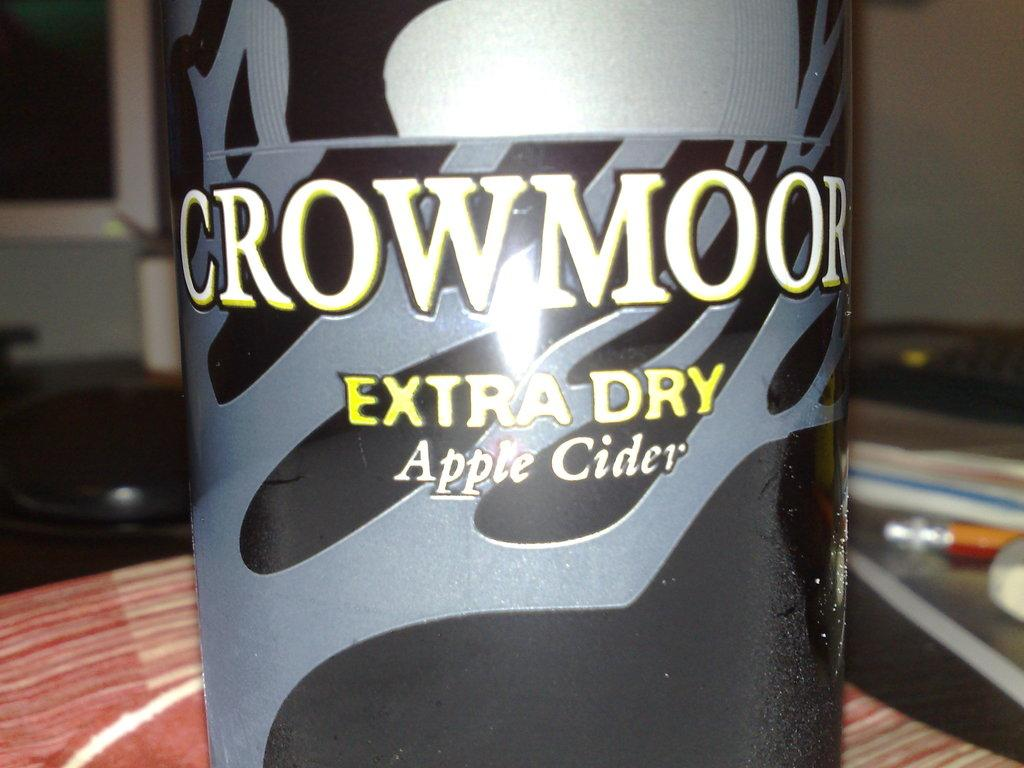<image>
Summarize the visual content of the image. CrowMoor extra dry apple cider in a bottle. 